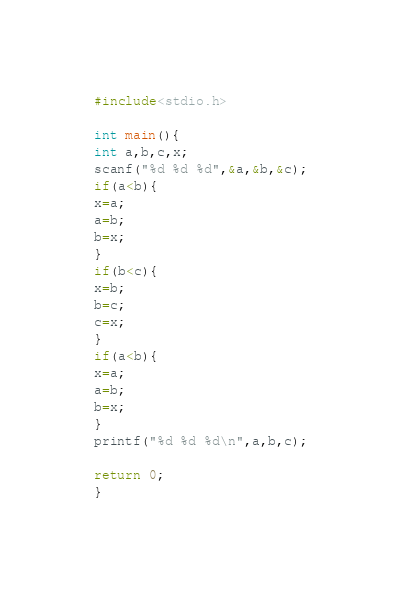Convert code to text. <code><loc_0><loc_0><loc_500><loc_500><_C++_>#include<stdio.h>

int main(){
int a,b,c,x;
scanf("%d %d %d",&a,&b,&c);
if(a<b){
x=a;
a=b;
b=x;
}
if(b<c){
x=b;
b=c;
c=x;
}
if(a<b){
x=a;
a=b;
b=x;
}
printf("%d %d %d\n",a,b,c);

return 0;
}</code> 